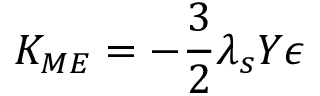Convert formula to latex. <formula><loc_0><loc_0><loc_500><loc_500>K _ { M E } = - \frac { 3 } { 2 } \lambda _ { s } Y \epsilon</formula> 